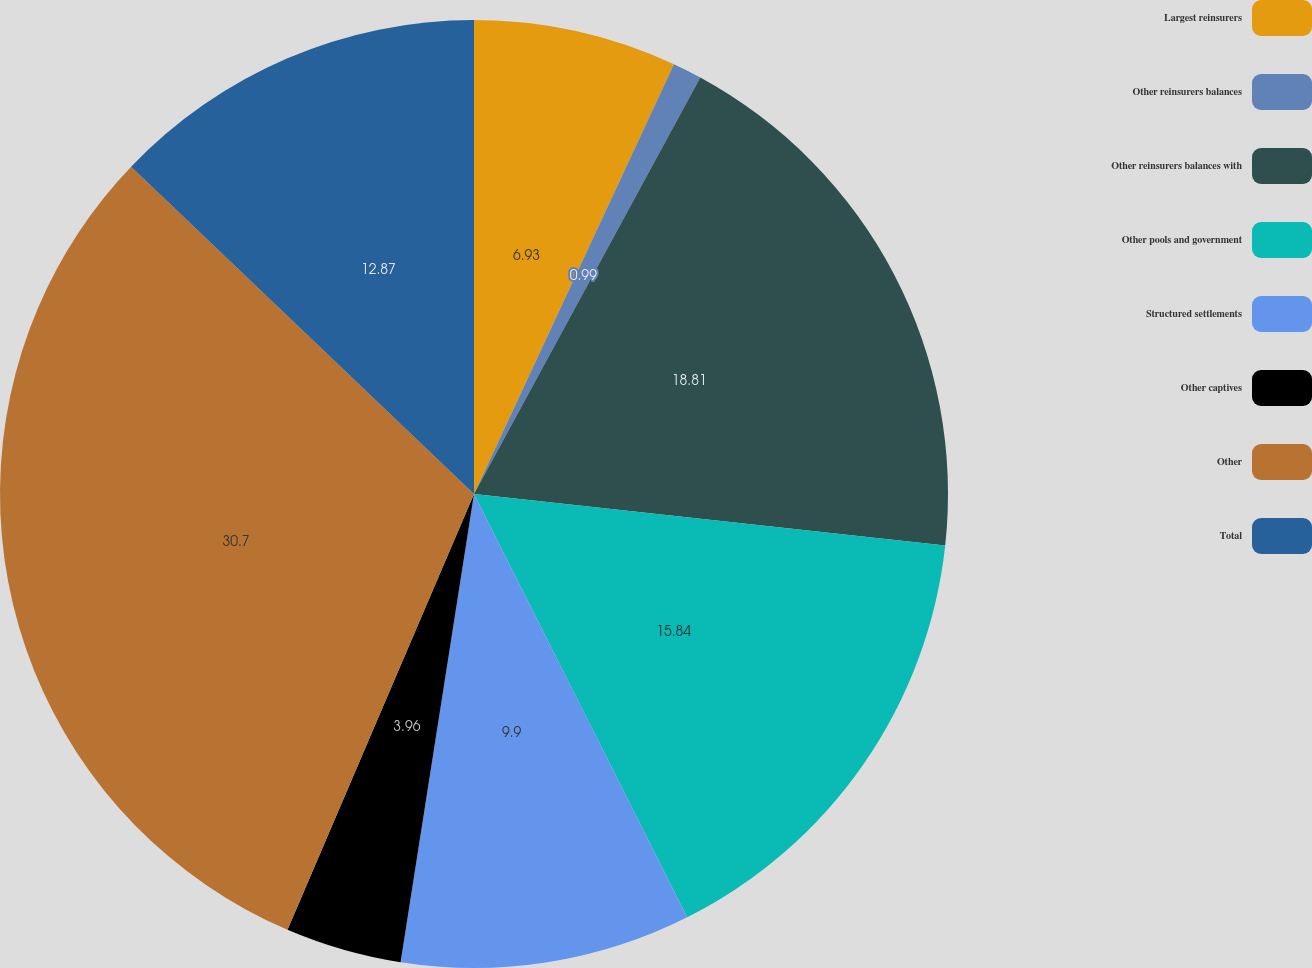<chart> <loc_0><loc_0><loc_500><loc_500><pie_chart><fcel>Largest reinsurers<fcel>Other reinsurers balances<fcel>Other reinsurers balances with<fcel>Other pools and government<fcel>Structured settlements<fcel>Other captives<fcel>Other<fcel>Total<nl><fcel>6.93%<fcel>0.99%<fcel>18.81%<fcel>15.84%<fcel>9.9%<fcel>3.96%<fcel>30.69%<fcel>12.87%<nl></chart> 